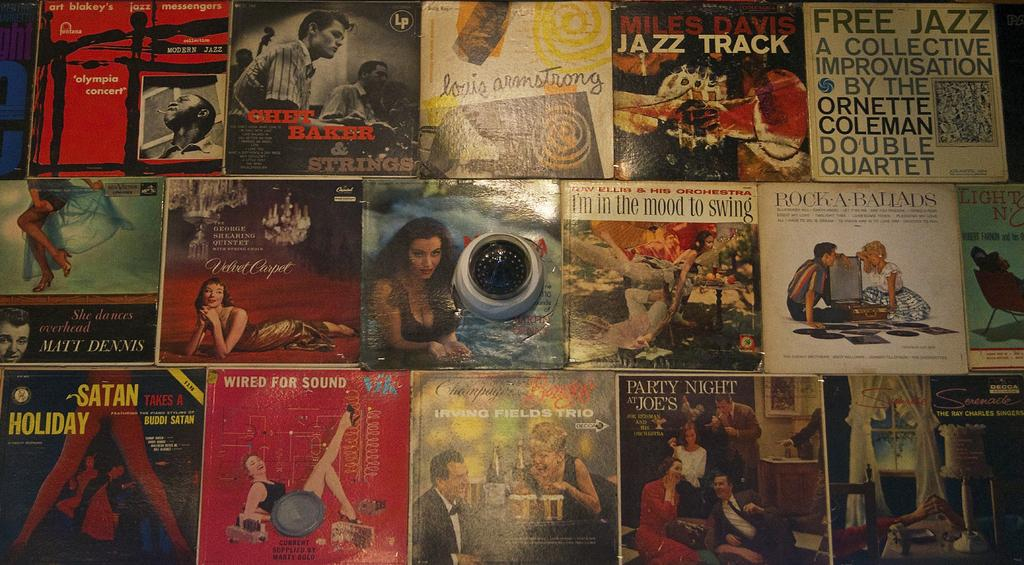<image>
Relay a brief, clear account of the picture shown. a collections of various jazz and swing album covers 